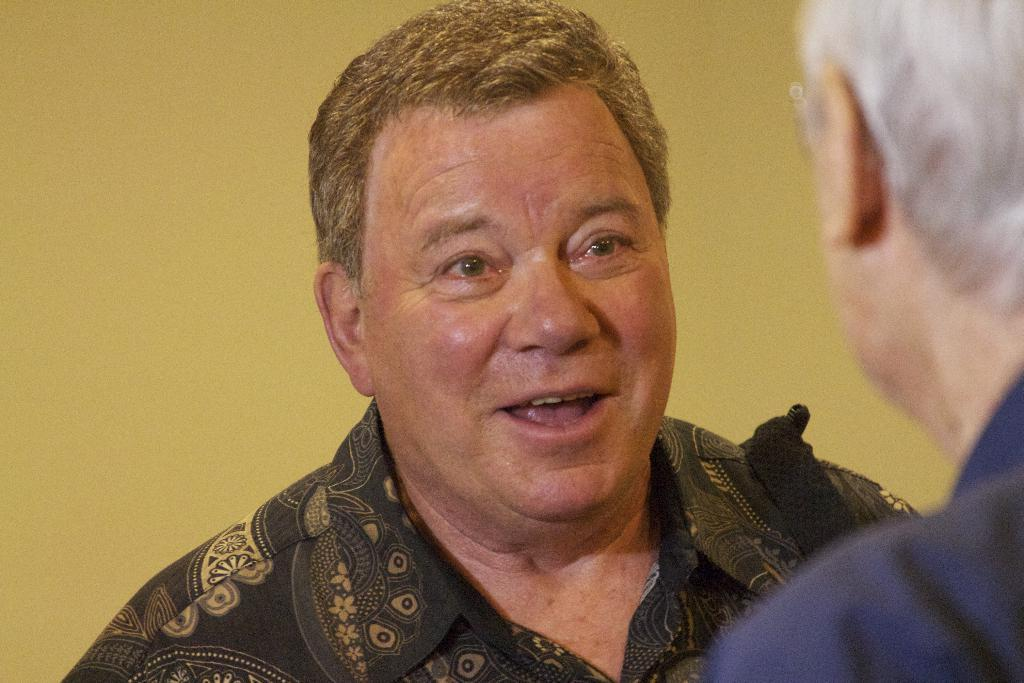How many people are in the image? There are two men in the image. What can be observed about the background of the image? The background of the image is yellow. What type of fuel is being used by the icicle in the image? There is no icicle present in the image, so it is not possible to determine what type of fuel it might be using. 